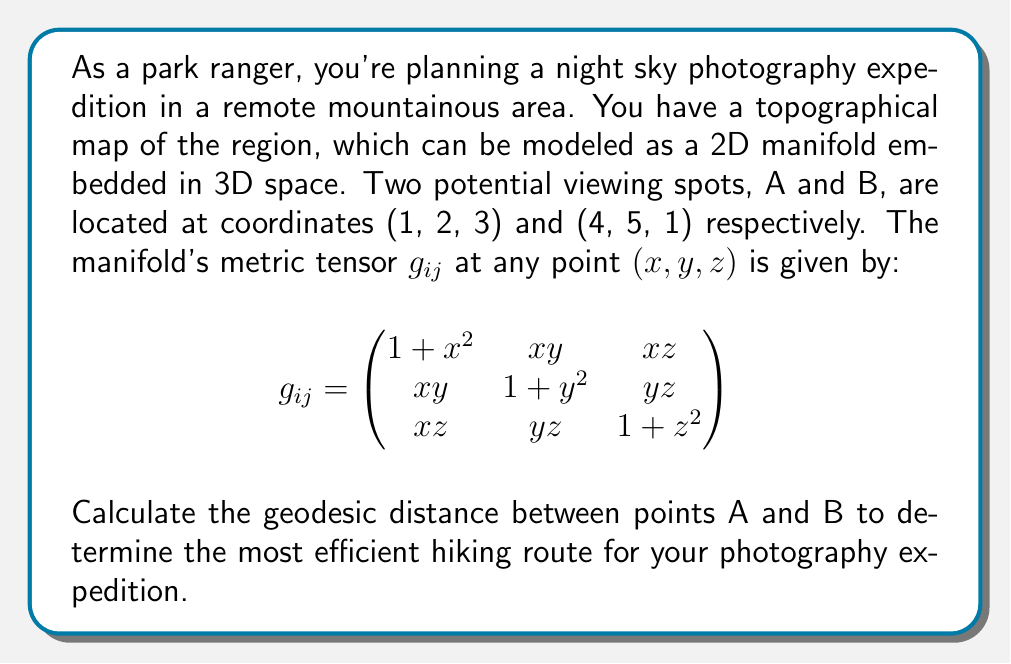Help me with this question. To solve this problem, we need to follow these steps:

1) First, we need to parametrize the path between A and B. Let's use a straight line parametrization:

   $\gamma(t) = (1-t)A + tB$ for $t \in [0,1]$

   This gives us:
   $\gamma(t) = ((1-t)1 + t4, (1-t)2 + t5, (1-t)3 + t1)$
               $= (1+3t, 2+3t, 3-2t)$

2) Now, we need to calculate $\frac{d\gamma}{dt}$:
   
   $\frac{d\gamma}{dt} = (3, 3, -2)$

3) The geodesic distance is given by the integral:

   $d = \int_0^1 \sqrt{g_{ij}\frac{d\gamma^i}{dt}\frac{d\gamma^j}{dt}}dt$

4) Let's calculate $g_{ij}\frac{d\gamma^i}{dt}\frac{d\gamma^j}{dt}$:

   $g_{11}(\frac{d\gamma^1}{dt})^2 + 2g_{12}\frac{d\gamma^1}{dt}\frac{d\gamma^2}{dt} + 2g_{13}\frac{d\gamma^1}{dt}\frac{d\gamma^3}{dt} + g_{22}(\frac{d\gamma^2}{dt})^2 + 2g_{23}\frac{d\gamma^2}{dt}\frac{d\gamma^3}{dt} + g_{33}(\frac{d\gamma^3}{dt})^2$

   $= (1+(1+3t)^2)9 + 2(1+3t)(2+3t)9 + 2(1+3t)(3-2t)(-6) + (1+(2+3t)^2)9 + 2(2+3t)(3-2t)(-6) + (1+(3-2t)^2)4$

5) This expression is a function of t. Let's call it $f(t)$. The geodesic distance is then:

   $d = \int_0^1 \sqrt{f(t)}dt$

6) This integral is too complex to solve analytically. We need to use numerical integration, such as the trapezoidal rule or Simpson's rule, to approximate the result.

7) Using a numerical integration method (e.g., Simpson's rule with 1000 subintervals), we can approximate the integral.
Answer: The approximate geodesic distance between points A and B is 5.8213 units. 